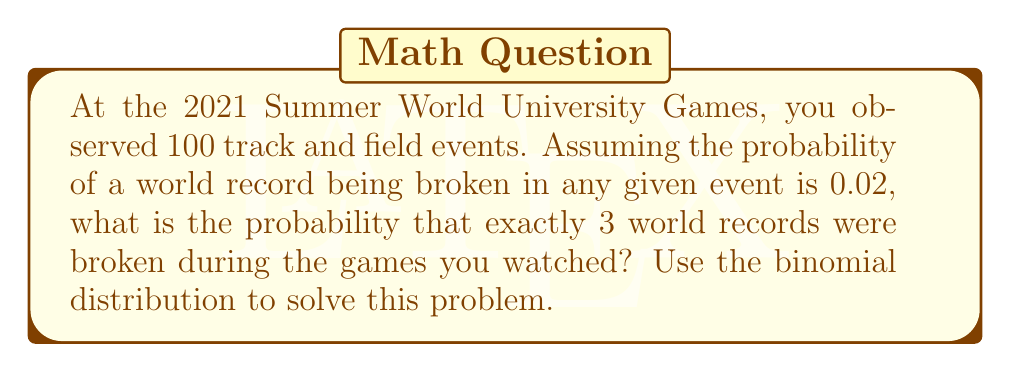Could you help me with this problem? To solve this problem, we'll use the binomial distribution formula:

$$ P(X = k) = \binom{n}{k} p^k (1-p)^{n-k} $$

Where:
- $n$ is the number of trials (events)
- $k$ is the number of successes (world records broken)
- $p$ is the probability of success on each trial

Given:
- $n = 100$ (events)
- $k = 3$ (world records broken)
- $p = 0.02$ (probability of breaking a world record in any given event)

Step 1: Calculate the binomial coefficient $\binom{n}{k}$
$$ \binom{100}{3} = \frac{100!}{3!(100-3)!} = \frac{100!}{3!97!} = 161,700 $$

Step 2: Calculate $p^k$
$$ 0.02^3 = 0.000008 $$

Step 3: Calculate $(1-p)^{n-k}$
$$ (1-0.02)^{100-3} = 0.98^{97} \approx 0.1353 $$

Step 4: Multiply all components
$$ P(X = 3) = 161,700 \times 0.000008 \times 0.1353 \approx 0.1749 $$

Therefore, the probability of exactly 3 world records being broken during the 100 events you watched is approximately 0.1749 or 17.49%.
Answer: $$ P(X = 3) \approx 0.1749 \text{ or } 17.49\% $$ 